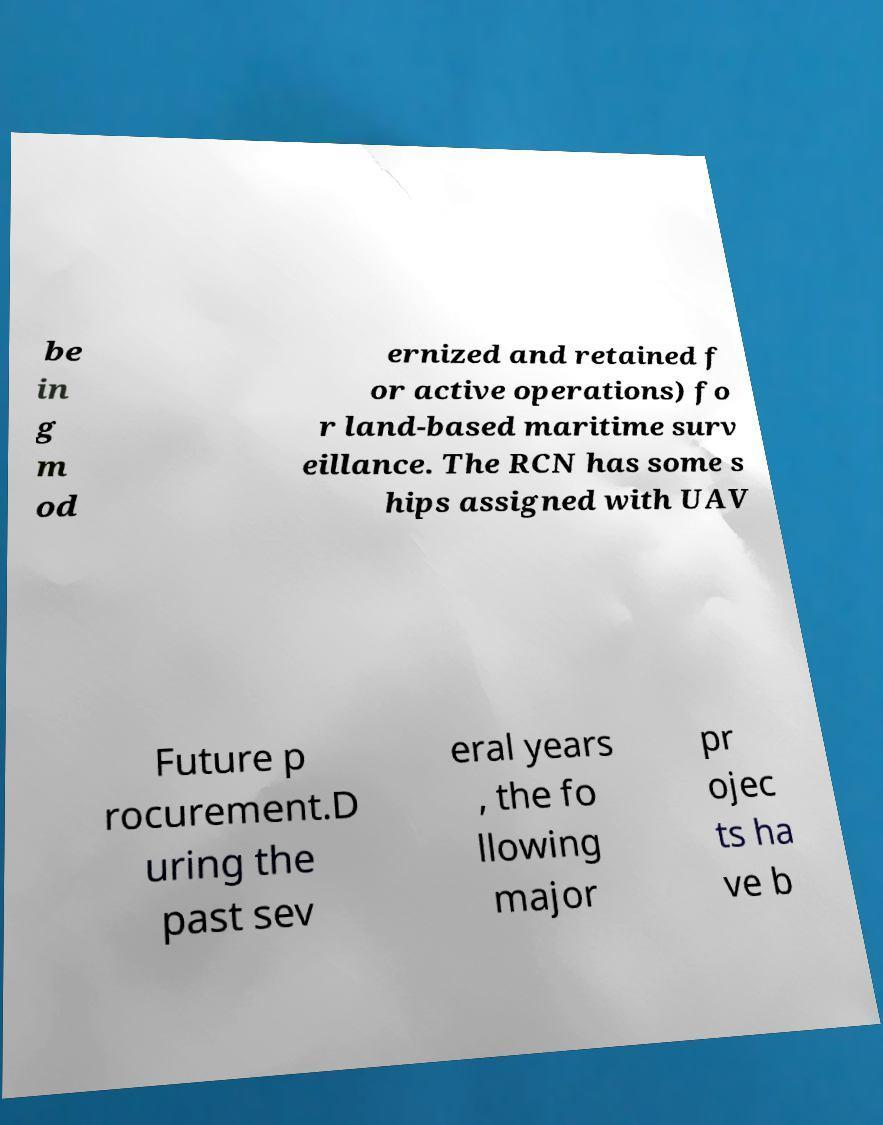For documentation purposes, I need the text within this image transcribed. Could you provide that? be in g m od ernized and retained f or active operations) fo r land-based maritime surv eillance. The RCN has some s hips assigned with UAV Future p rocurement.D uring the past sev eral years , the fo llowing major pr ojec ts ha ve b 